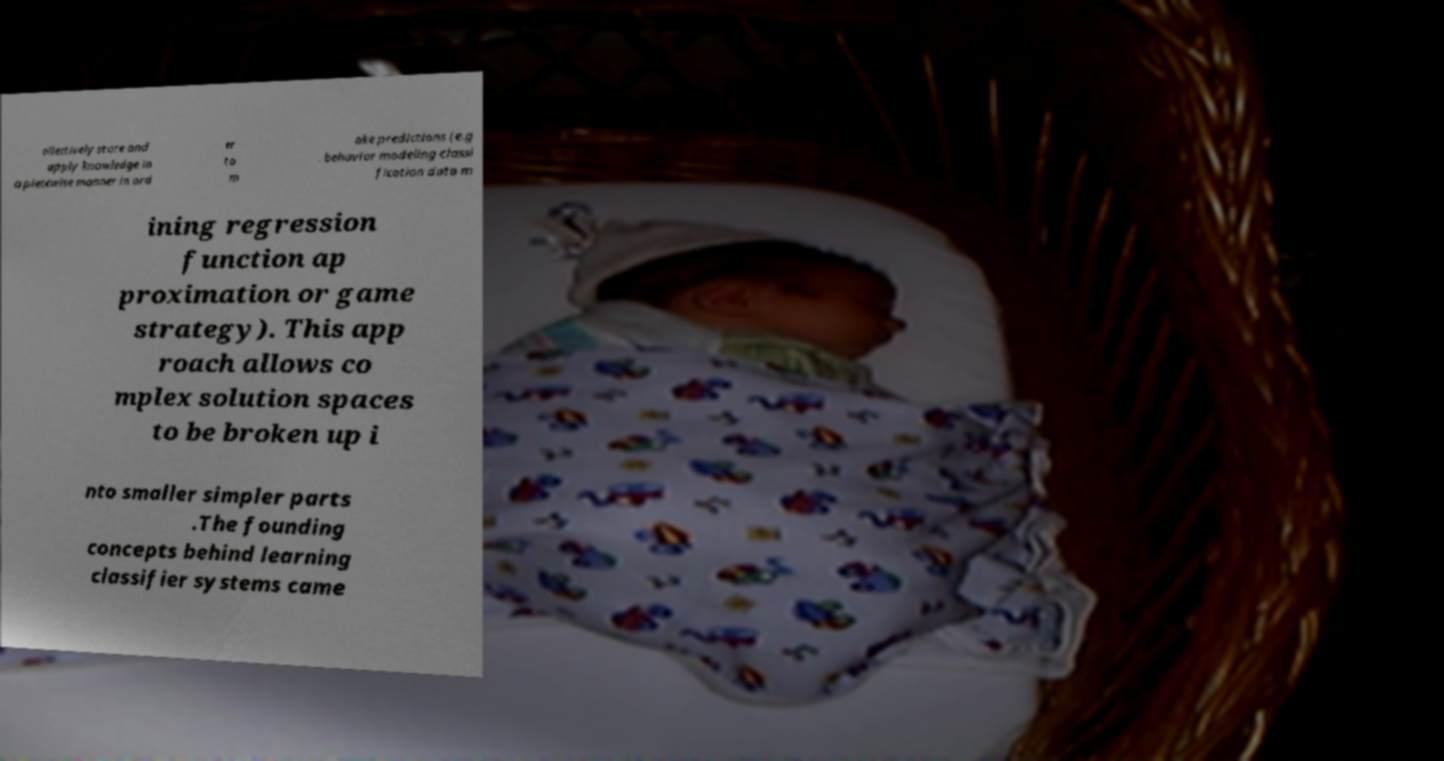Could you extract and type out the text from this image? ollectively store and apply knowledge in a piecewise manner in ord er to m ake predictions (e.g . behavior modeling classi fication data m ining regression function ap proximation or game strategy). This app roach allows co mplex solution spaces to be broken up i nto smaller simpler parts .The founding concepts behind learning classifier systems came 